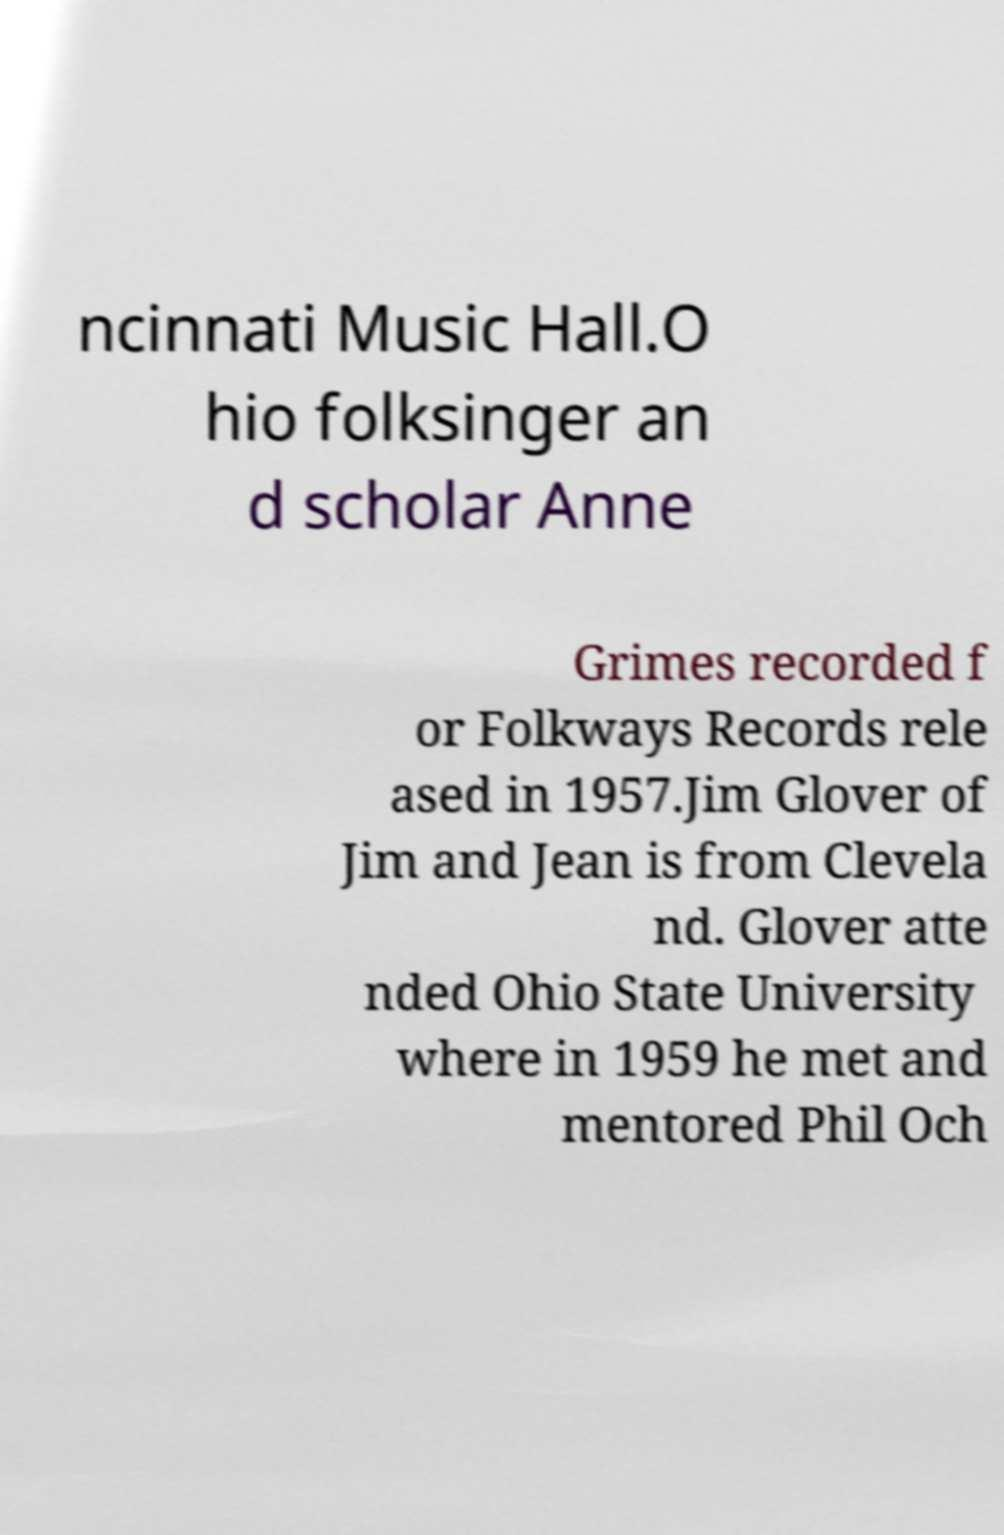Could you assist in decoding the text presented in this image and type it out clearly? ncinnati Music Hall.O hio folksinger an d scholar Anne Grimes recorded f or Folkways Records rele ased in 1957.Jim Glover of Jim and Jean is from Clevela nd. Glover atte nded Ohio State University where in 1959 he met and mentored Phil Och 